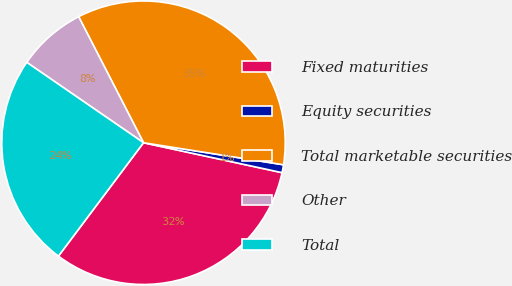<chart> <loc_0><loc_0><loc_500><loc_500><pie_chart><fcel>Fixed maturities<fcel>Equity securities<fcel>Total marketable securities<fcel>Other<fcel>Total<nl><fcel>31.86%<fcel>0.9%<fcel>35.05%<fcel>7.84%<fcel>24.35%<nl></chart> 